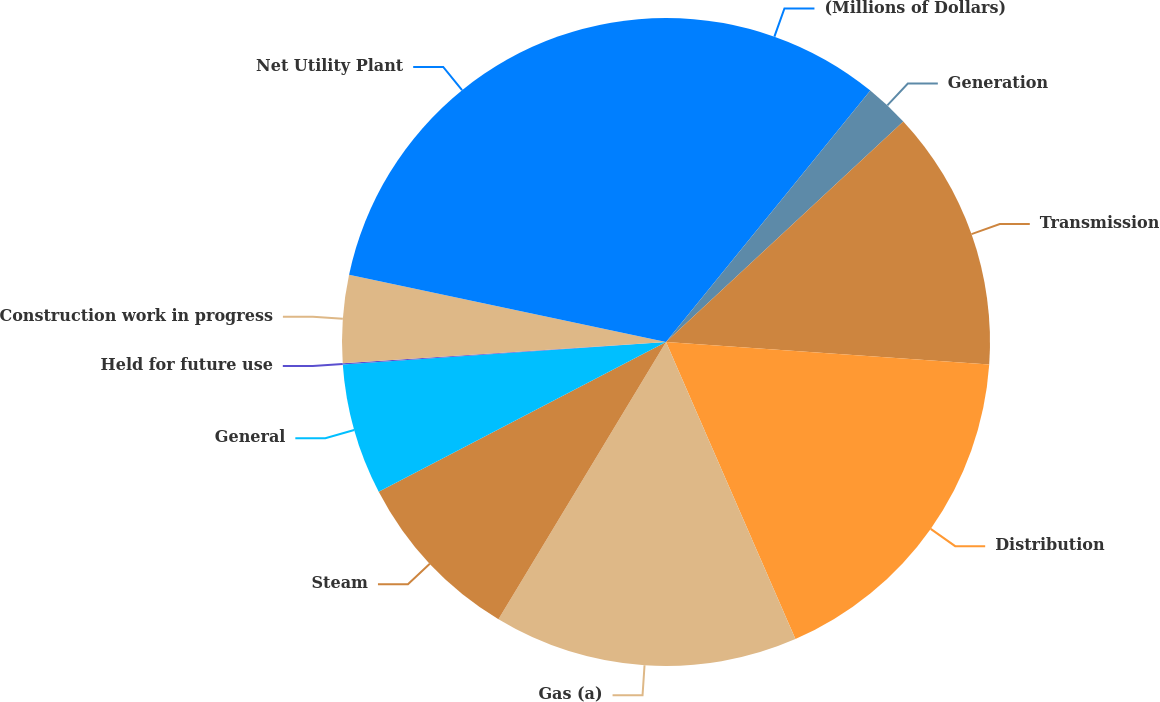<chart> <loc_0><loc_0><loc_500><loc_500><pie_chart><fcel>(Millions of Dollars)<fcel>Generation<fcel>Transmission<fcel>Distribution<fcel>Gas (a)<fcel>Steam<fcel>General<fcel>Held for future use<fcel>Construction work in progress<fcel>Net Utility Plant<nl><fcel>10.86%<fcel>2.22%<fcel>13.03%<fcel>17.35%<fcel>15.19%<fcel>8.7%<fcel>6.54%<fcel>0.06%<fcel>4.38%<fcel>21.67%<nl></chart> 